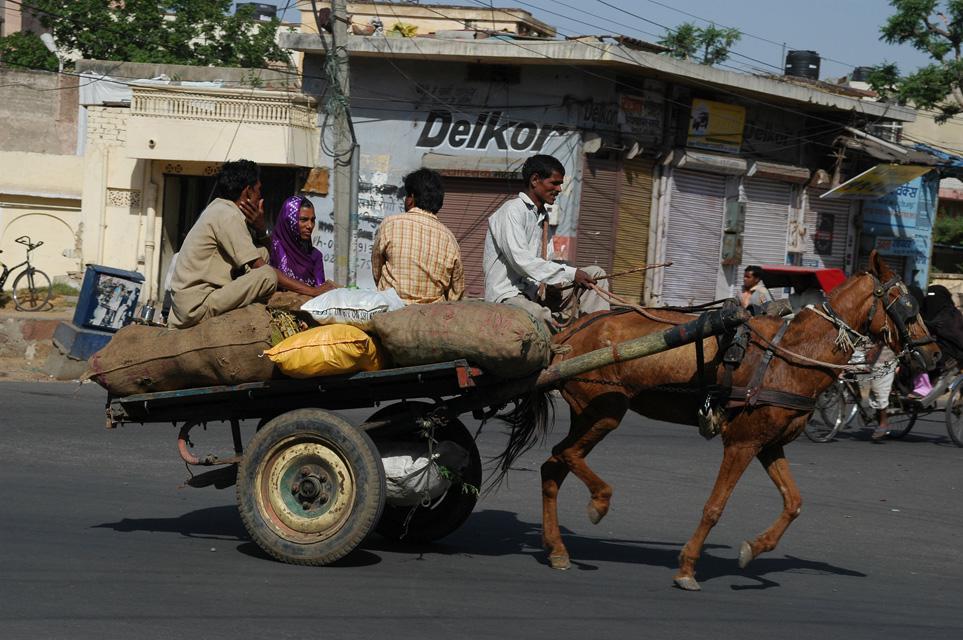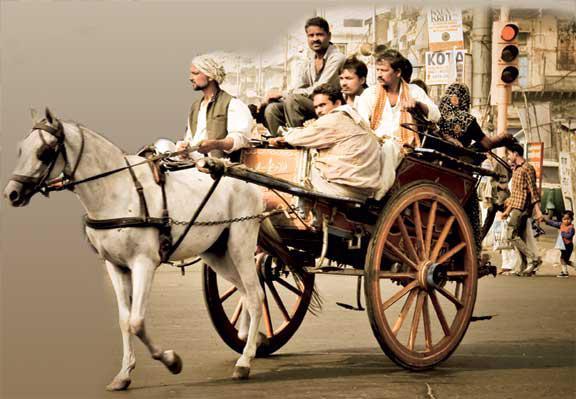The first image is the image on the left, the second image is the image on the right. Analyze the images presented: Is the assertion "The image on the ride has a horse with a red tassel on its head." valid? Answer yes or no. No. The first image is the image on the left, the second image is the image on the right. Given the left and right images, does the statement "There is only one person riding in the cart in one of the images." hold true? Answer yes or no. No. 